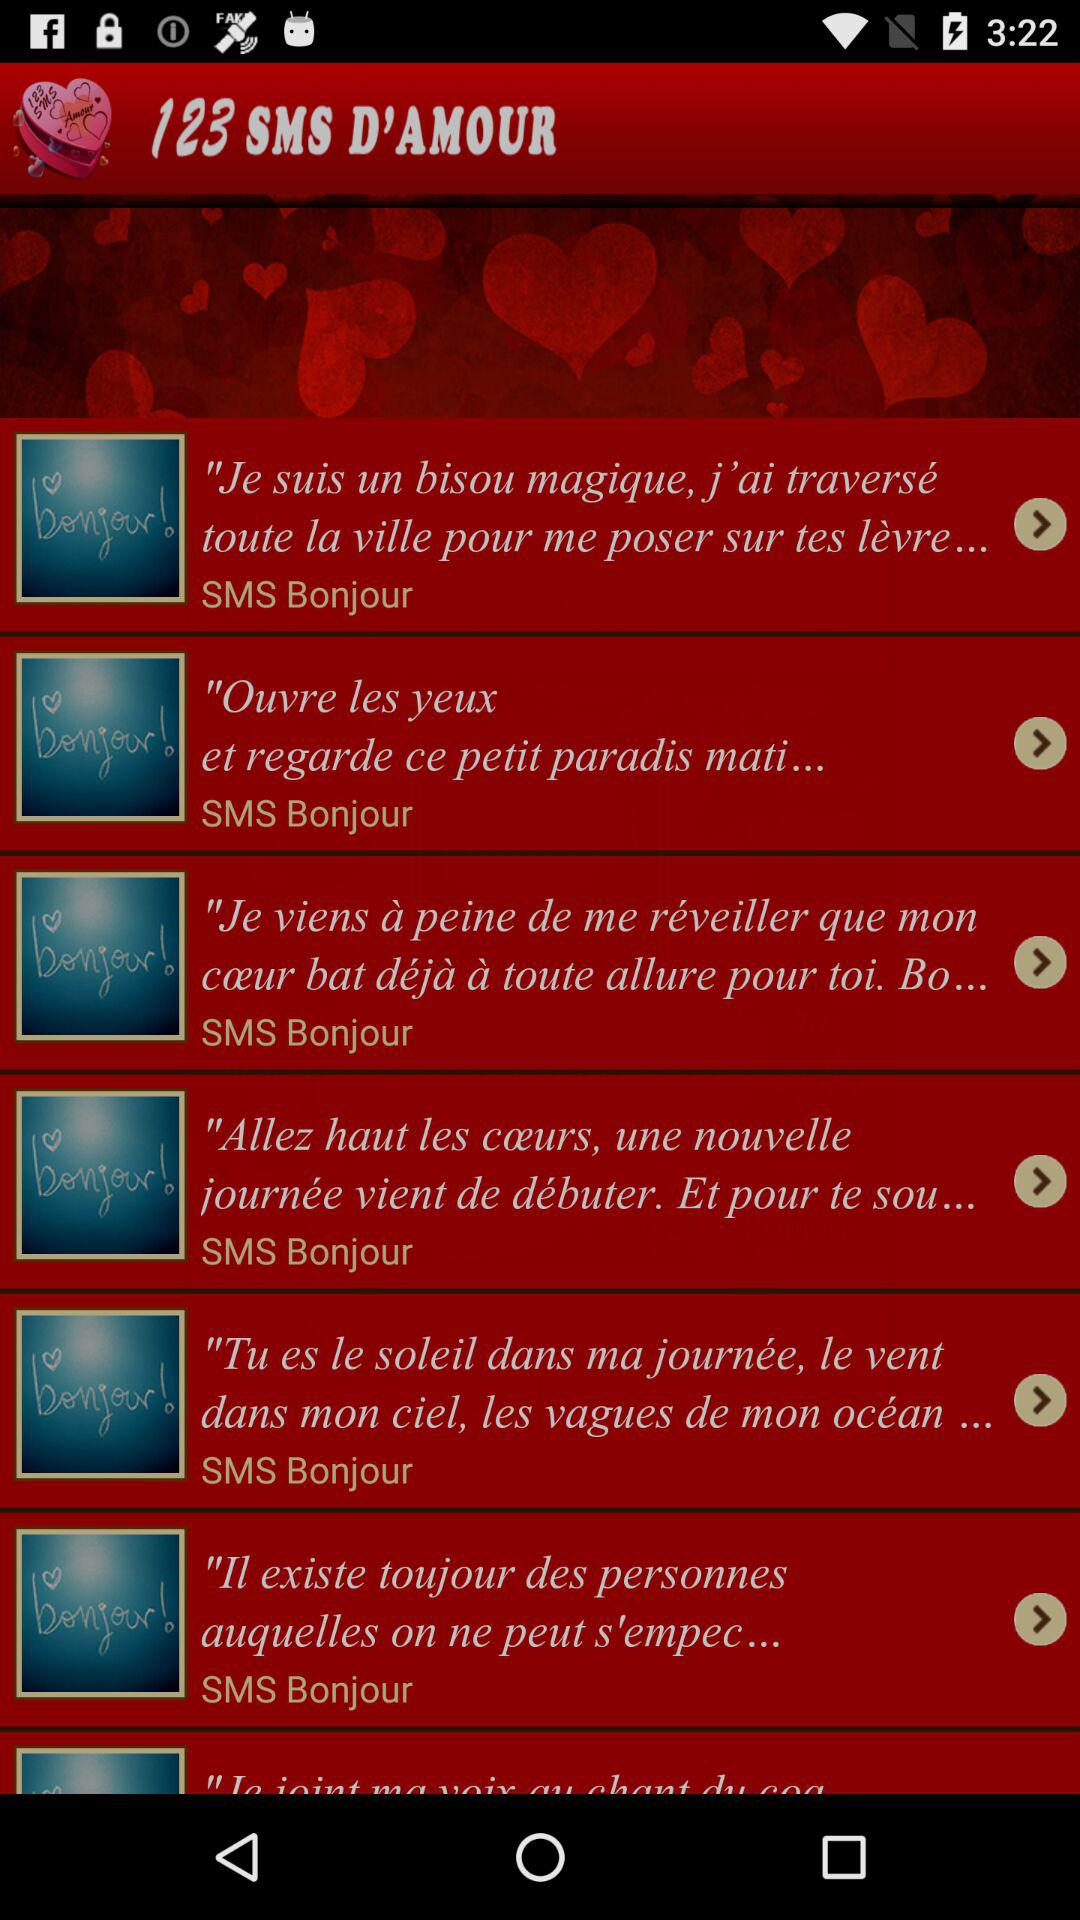Which version of the application is this?
When the provided information is insufficient, respond with <no answer>. <no answer> 